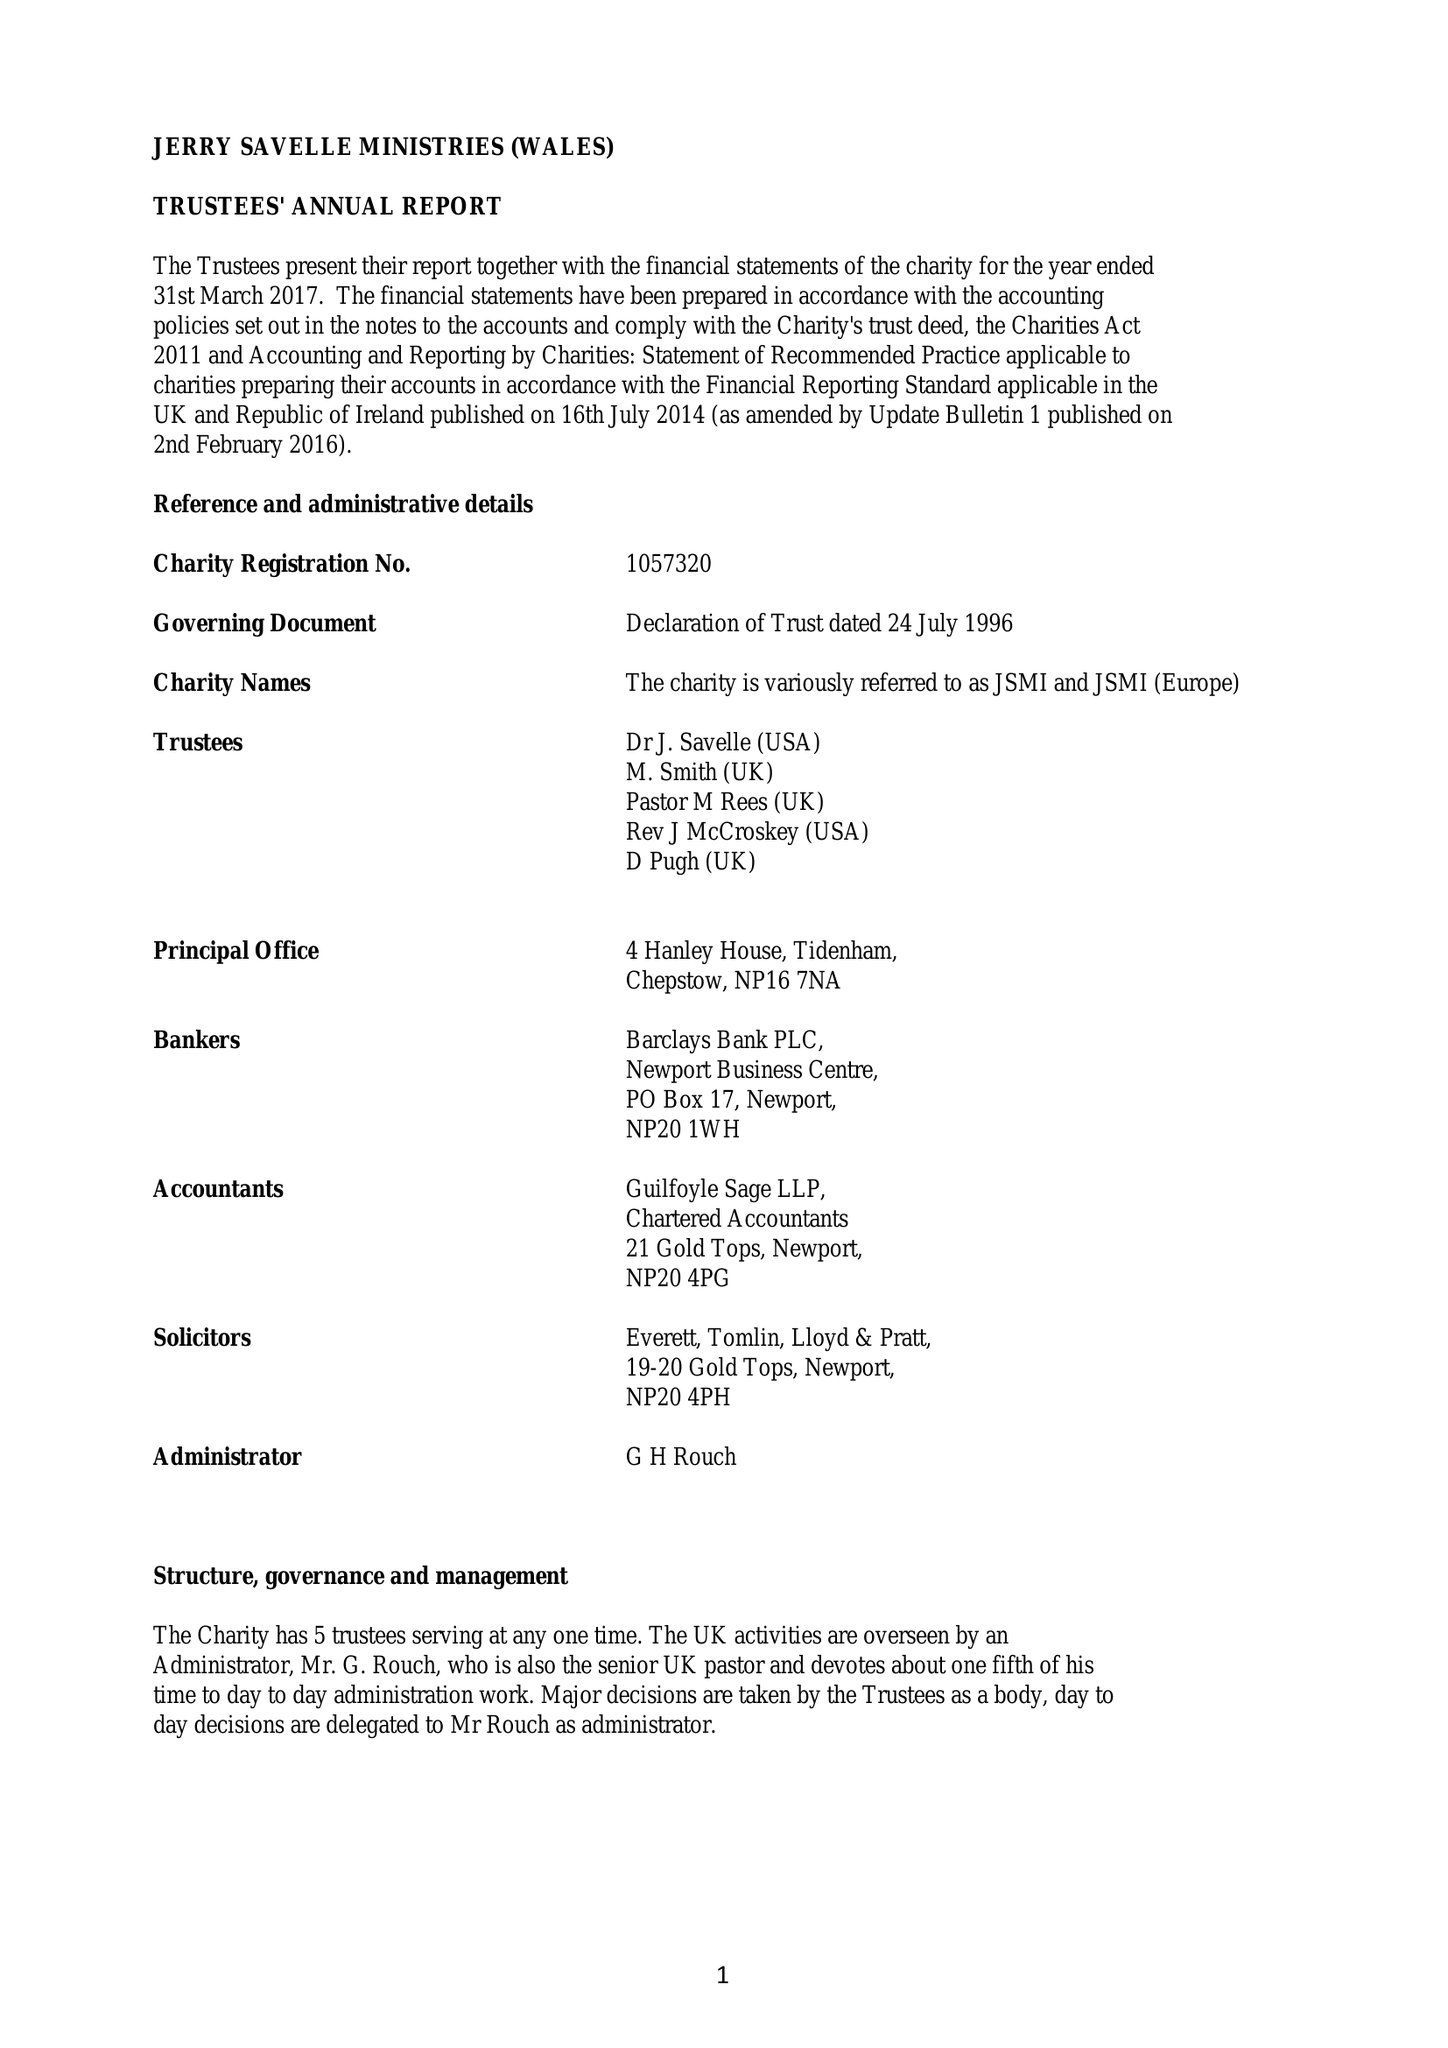What is the value for the address__postcode?
Answer the question using a single word or phrase. NP16 7NA 